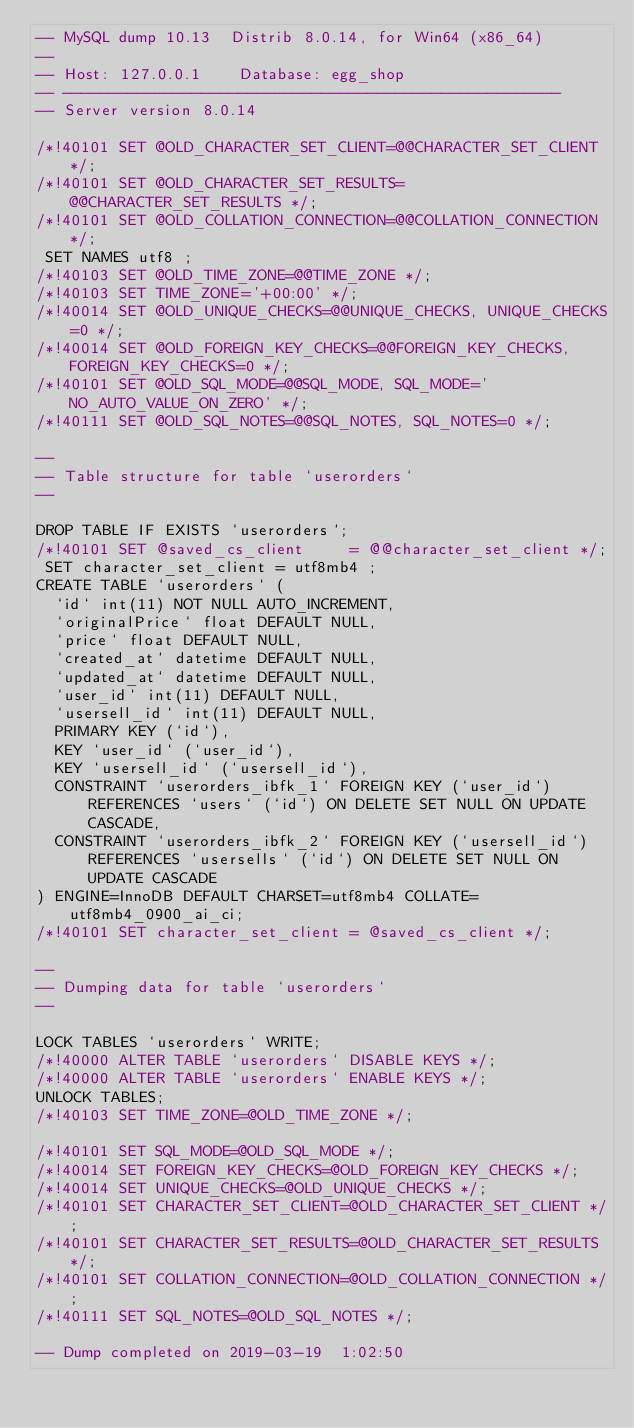Convert code to text. <code><loc_0><loc_0><loc_500><loc_500><_SQL_>-- MySQL dump 10.13  Distrib 8.0.14, for Win64 (x86_64)
--
-- Host: 127.0.0.1    Database: egg_shop
-- ------------------------------------------------------
-- Server version	8.0.14

/*!40101 SET @OLD_CHARACTER_SET_CLIENT=@@CHARACTER_SET_CLIENT */;
/*!40101 SET @OLD_CHARACTER_SET_RESULTS=@@CHARACTER_SET_RESULTS */;
/*!40101 SET @OLD_COLLATION_CONNECTION=@@COLLATION_CONNECTION */;
 SET NAMES utf8 ;
/*!40103 SET @OLD_TIME_ZONE=@@TIME_ZONE */;
/*!40103 SET TIME_ZONE='+00:00' */;
/*!40014 SET @OLD_UNIQUE_CHECKS=@@UNIQUE_CHECKS, UNIQUE_CHECKS=0 */;
/*!40014 SET @OLD_FOREIGN_KEY_CHECKS=@@FOREIGN_KEY_CHECKS, FOREIGN_KEY_CHECKS=0 */;
/*!40101 SET @OLD_SQL_MODE=@@SQL_MODE, SQL_MODE='NO_AUTO_VALUE_ON_ZERO' */;
/*!40111 SET @OLD_SQL_NOTES=@@SQL_NOTES, SQL_NOTES=0 */;

--
-- Table structure for table `userorders`
--

DROP TABLE IF EXISTS `userorders`;
/*!40101 SET @saved_cs_client     = @@character_set_client */;
 SET character_set_client = utf8mb4 ;
CREATE TABLE `userorders` (
  `id` int(11) NOT NULL AUTO_INCREMENT,
  `originalPrice` float DEFAULT NULL,
  `price` float DEFAULT NULL,
  `created_at` datetime DEFAULT NULL,
  `updated_at` datetime DEFAULT NULL,
  `user_id` int(11) DEFAULT NULL,
  `usersell_id` int(11) DEFAULT NULL,
  PRIMARY KEY (`id`),
  KEY `user_id` (`user_id`),
  KEY `usersell_id` (`usersell_id`),
  CONSTRAINT `userorders_ibfk_1` FOREIGN KEY (`user_id`) REFERENCES `users` (`id`) ON DELETE SET NULL ON UPDATE CASCADE,
  CONSTRAINT `userorders_ibfk_2` FOREIGN KEY (`usersell_id`) REFERENCES `usersells` (`id`) ON DELETE SET NULL ON UPDATE CASCADE
) ENGINE=InnoDB DEFAULT CHARSET=utf8mb4 COLLATE=utf8mb4_0900_ai_ci;
/*!40101 SET character_set_client = @saved_cs_client */;

--
-- Dumping data for table `userorders`
--

LOCK TABLES `userorders` WRITE;
/*!40000 ALTER TABLE `userorders` DISABLE KEYS */;
/*!40000 ALTER TABLE `userorders` ENABLE KEYS */;
UNLOCK TABLES;
/*!40103 SET TIME_ZONE=@OLD_TIME_ZONE */;

/*!40101 SET SQL_MODE=@OLD_SQL_MODE */;
/*!40014 SET FOREIGN_KEY_CHECKS=@OLD_FOREIGN_KEY_CHECKS */;
/*!40014 SET UNIQUE_CHECKS=@OLD_UNIQUE_CHECKS */;
/*!40101 SET CHARACTER_SET_CLIENT=@OLD_CHARACTER_SET_CLIENT */;
/*!40101 SET CHARACTER_SET_RESULTS=@OLD_CHARACTER_SET_RESULTS */;
/*!40101 SET COLLATION_CONNECTION=@OLD_COLLATION_CONNECTION */;
/*!40111 SET SQL_NOTES=@OLD_SQL_NOTES */;

-- Dump completed on 2019-03-19  1:02:50
</code> 